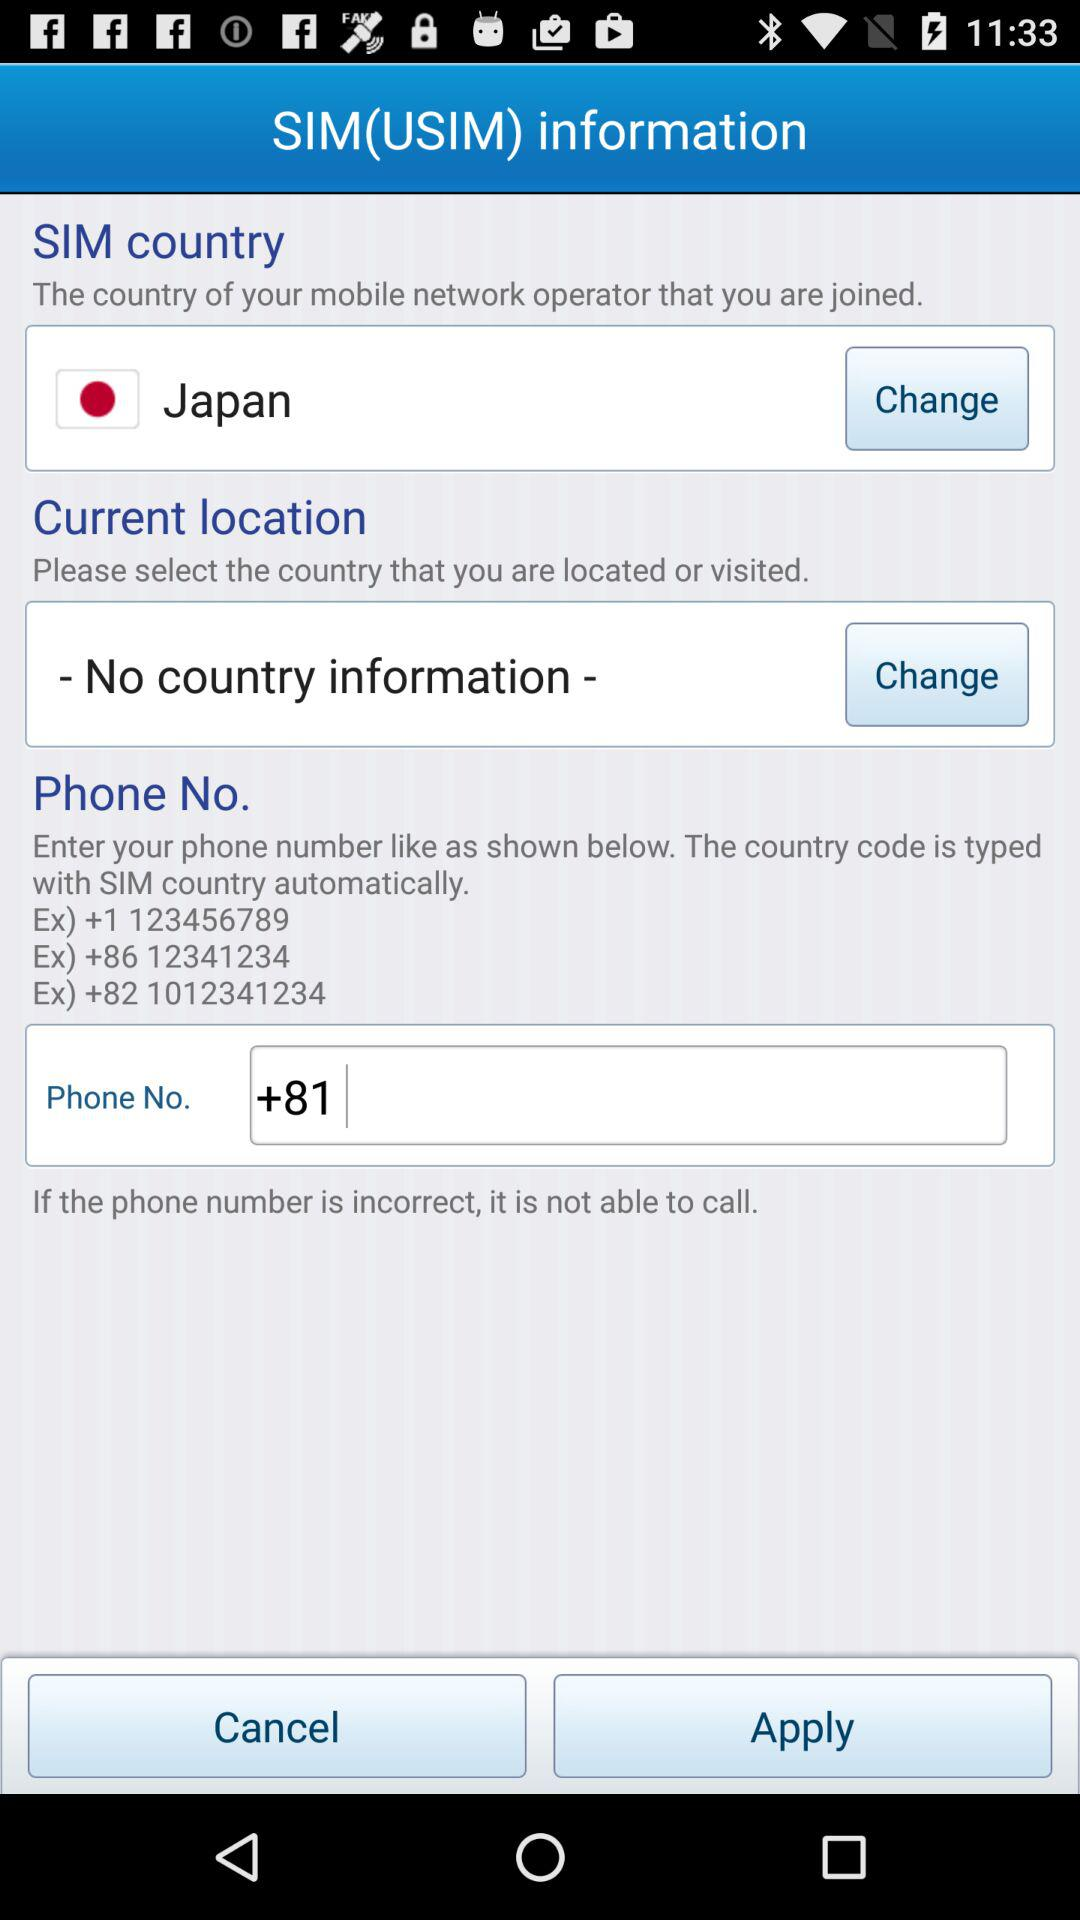What is the number starting with the country code +86? The number starting with the country code +86 is 12341234. 